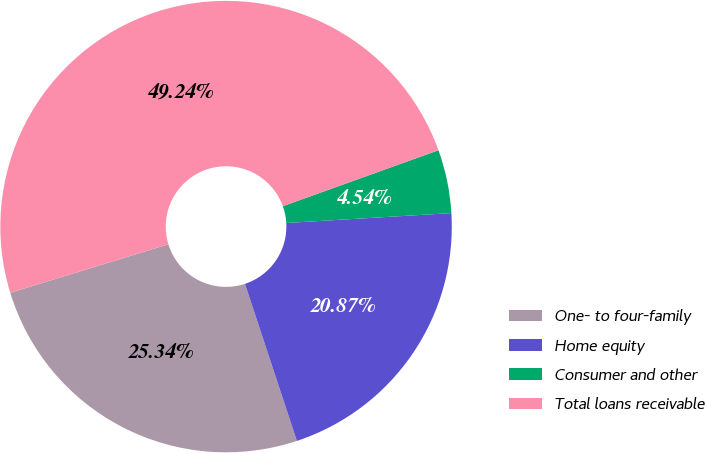Convert chart. <chart><loc_0><loc_0><loc_500><loc_500><pie_chart><fcel>One- to four-family<fcel>Home equity<fcel>Consumer and other<fcel>Total loans receivable<nl><fcel>25.34%<fcel>20.87%<fcel>4.54%<fcel>49.24%<nl></chart> 